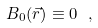<formula> <loc_0><loc_0><loc_500><loc_500>B _ { 0 } ( \vec { r } ) \equiv 0 \ ,</formula> 